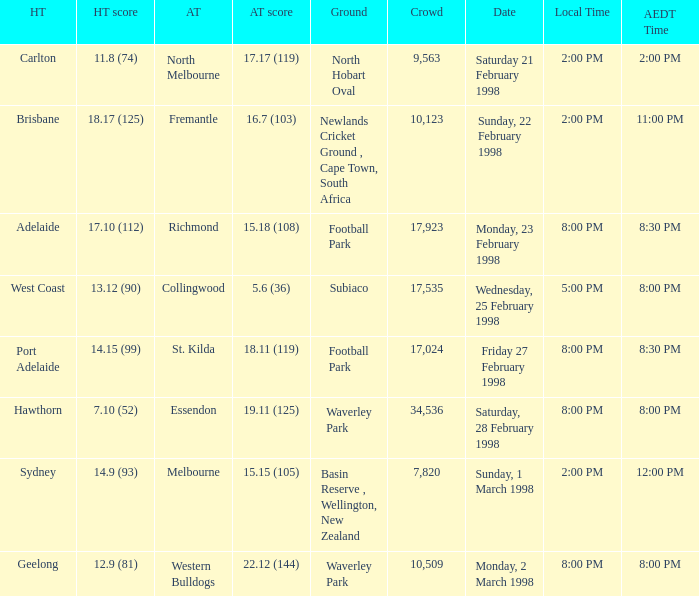Name the AEDT Time which has a Local Time of 8:00 pm, and a Away team score of 22.12 (144)? 8:00 PM. 